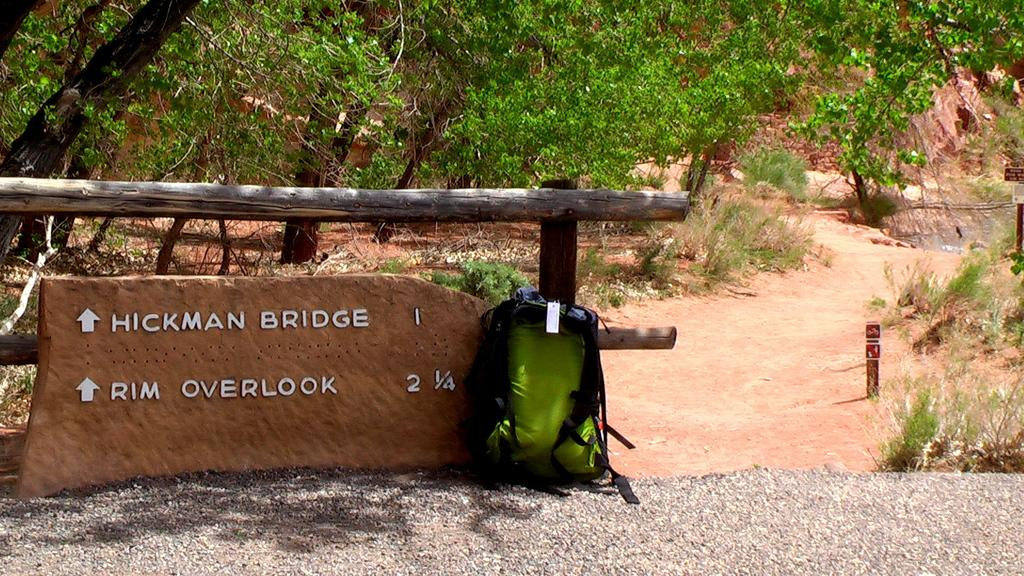What type of bag is visible in the image? There is a travel backpack in the image. What text can be seen on a brick stone in the image? The words "Hickman Bridge" are written on a brick stone in the image. What type of vegetation is visible in the background of the image? There are trees visible in the background of the image. What type of fruit is being offered to the person in the image? There is no person or fruit present in the image. 